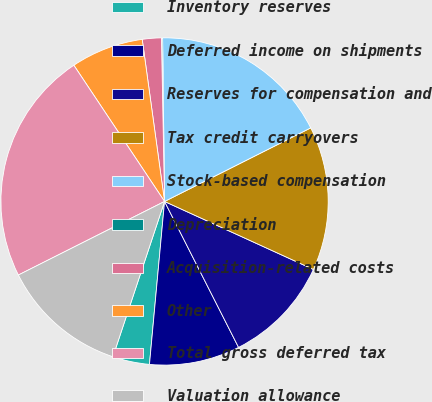Convert chart to OTSL. <chart><loc_0><loc_0><loc_500><loc_500><pie_chart><fcel>Inventory reserves<fcel>Deferred income on shipments<fcel>Reserves for compensation and<fcel>Tax credit carryovers<fcel>Stock-based compensation<fcel>Depreciation<fcel>Acquisition-related costs<fcel>Other<fcel>Total gross deferred tax<fcel>Valuation allowance<nl><fcel>3.64%<fcel>8.94%<fcel>10.71%<fcel>14.24%<fcel>17.77%<fcel>0.11%<fcel>1.88%<fcel>7.17%<fcel>23.07%<fcel>12.47%<nl></chart> 